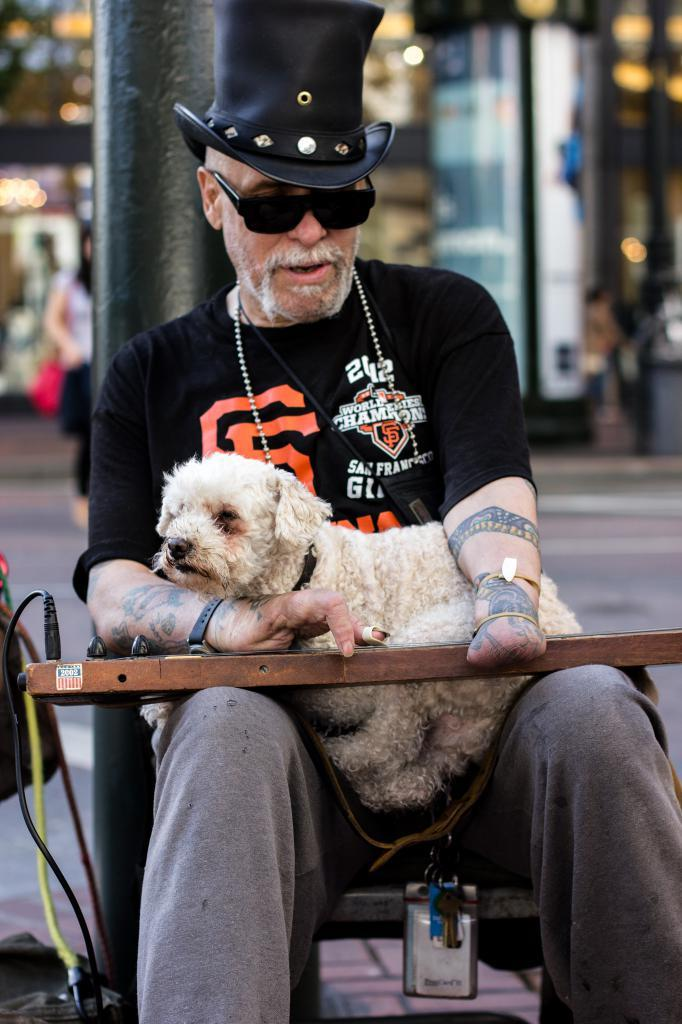What is the person in the image doing? The person is sitting on a chair in the image. What is the person holding in the image? The person is holding a puppy. What can be seen on the person's head in the image? The person is wearing a black hat. What is located beside the person in the image? There is a pole beside the person. What type of bubble is floating near the person's head in the image? There is no bubble present in the image; the person is wearing a black hat. What kind of pancake is the person eating in the image? There is no pancake present in the image; the person is holding a puppy. 